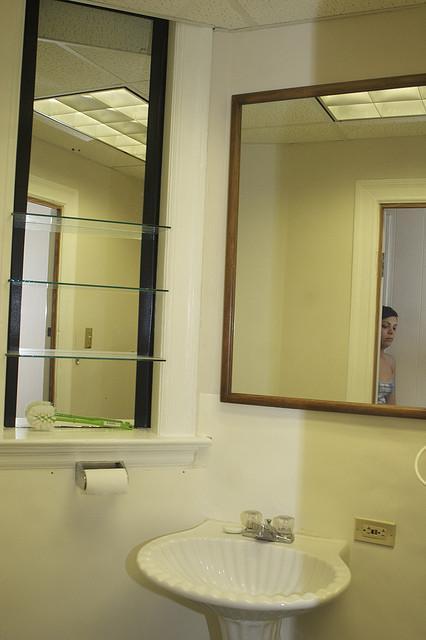How many sinks are here?
Give a very brief answer. 1. 